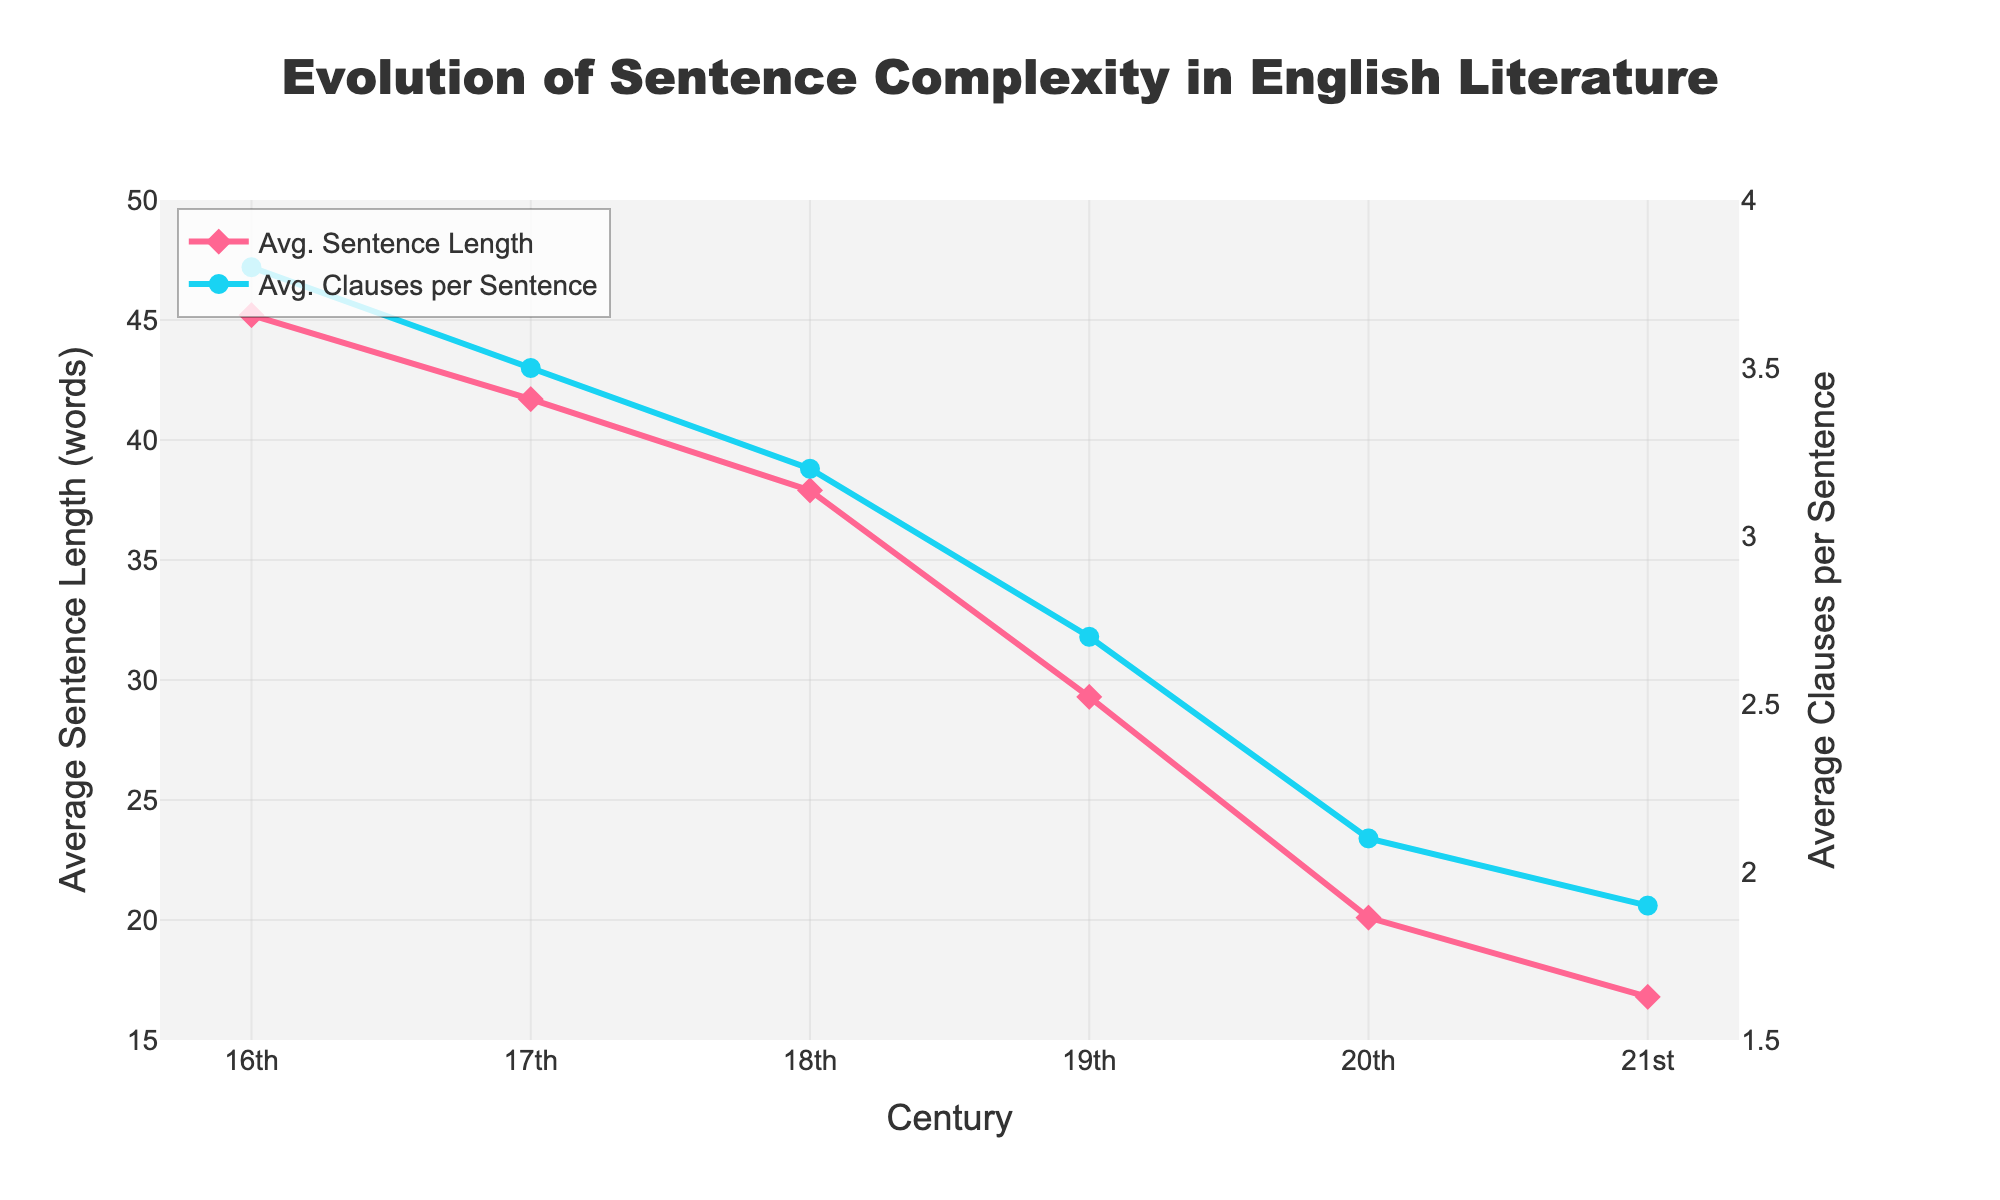What is the average sentence length in the 19th century? Locate the 19th century on the x-axis and refer to the corresponding value on the left y-axis labeled "Average Sentence Length (words)".
Answer: 29.3 How did the average sentence length change from the 16th to the 17th century? Compare the average sentence length in the 16th century (45.2 words) with that of the 17th century (41.7 words). Calculate the difference: 45.2 - 41.7 = 3.5 words.
Answer: Decreased by 3.5 words In which century did the average clauses per sentence drop below 2.0? Look at the right y-axis labeled "Average Clauses per Sentence" and find the point where the values first drop below 2.0. This is in the 21st century.
Answer: 21st century Which century has the highest average sentence length, and how do its clauses per sentence compare to other centuries? The highest average sentence length is in the 16th century with 45.2 words. The corresponding average clauses per sentence is 3.8, which is also the highest compared to other centuries.
Answer: 16th century, highest at 3.8 clauses How much did the average sentence length decrease between the 16th and the 19th centuries? Subtract the average sentence length of the 19th century (29.3 words) from that of the 16th century (45.2 words): 45.2 - 29.3 = 15.9 words.
Answer: Decreased by 15.9 words Which century shows the smallest difference between the average sentence length and average clauses per sentence, and what is the value of this difference? Calculate the difference for each century:
- 16th: 45.2 - 3.8 = 41.4
- 17th: 41.7 - 3.5 = 38.2
- 18th: 37.9 - 3.2 = 34.7
- 19th: 29.3 - 2.7 = 26.6
- 20th: 20.1 - 2.1 = 18.0
- 21st: 16.8 - 1.9 = 14.9
The smallest difference is in the 21st century (14.9).
Answer: 21st century, 14.9 By how many clauses per sentence did the value decrease between the 16th and the 21st centuries? Subtract the value in the 21st century (1.9 clauses) from the value in the 16th century (3.8 clauses): 3.8 - 1.9 = 1.9 clauses.
Answer: Decreased by 1.9 clauses When was the average sentence length equal to the average clauses per sentence? There is no point in the given data where the average sentence length equals the average clauses per sentence.
Answer: Never Which line in the plot is represented by blue markers, and what does it signify? Identify the line with the blue markers. It represents "Avg. Clauses per Sentence" as indicated by the legend.
Answer: Average Clauses per Sentence 